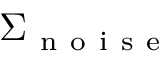Convert formula to latex. <formula><loc_0><loc_0><loc_500><loc_500>\Sigma _ { n o i s e }</formula> 